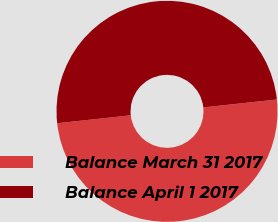<chart> <loc_0><loc_0><loc_500><loc_500><pie_chart><fcel>Balance March 31 2017<fcel>Balance April 1 2017<nl><fcel>49.99%<fcel>50.01%<nl></chart> 